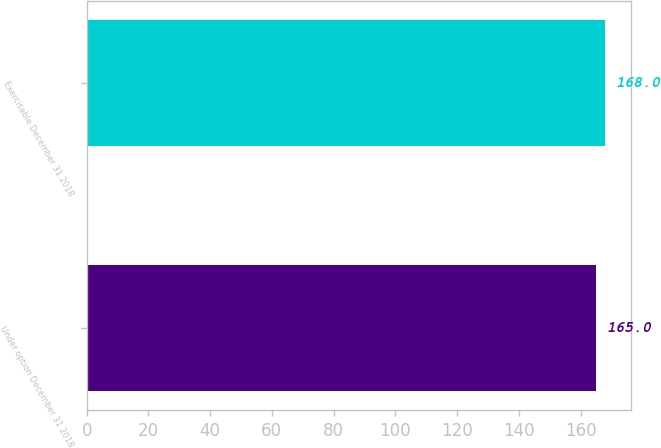<chart> <loc_0><loc_0><loc_500><loc_500><bar_chart><fcel>Under option December 31 2018<fcel>Exercisable December 31 2018<nl><fcel>165<fcel>168<nl></chart> 